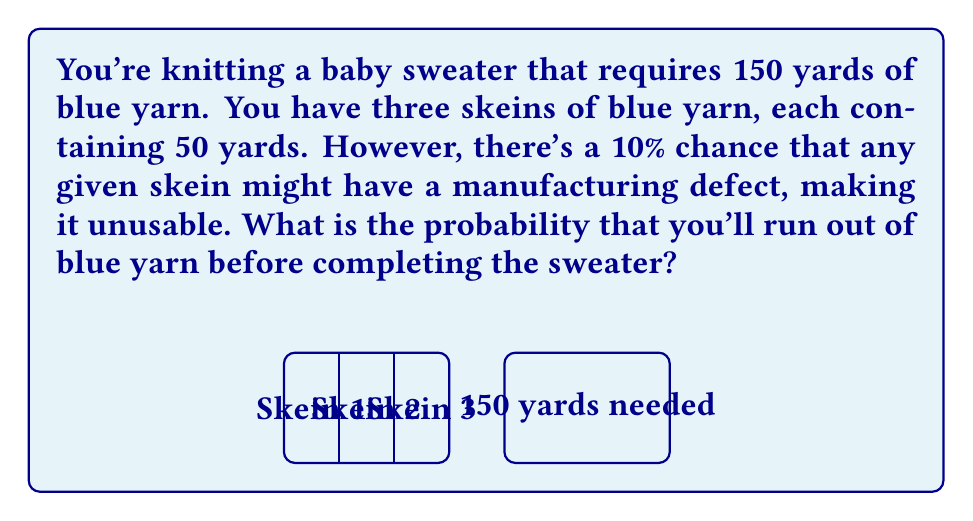Can you solve this math problem? Let's approach this step-by-step:

1) First, we need to calculate the probability of having enough usable yarn. This occurs when at least 3 skeins are usable.

2) The probability of a skein being usable is 90% or 0.9.

3) We can use the binomial probability formula to calculate the probability of exactly 3 skeins being usable:

   $$P(3\text{ usable}) = \binom{3}{3} \cdot 0.9^3 \cdot 0.1^0 = 0.729$$

4) The probability of all 3 skeins being usable is the same as the probability of not running out of yarn.

5) Therefore, the probability of running out of yarn is the complement of this probability:

   $$P(\text{running out}) = 1 - P(\text{not running out}) = 1 - 0.729 = 0.271$$

6) We can express this as a percentage: 0.271 * 100 = 27.1%
Answer: 27.1% 